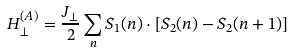<formula> <loc_0><loc_0><loc_500><loc_500>H ^ { ( A ) } _ { \perp } = \frac { J _ { \perp } } { 2 } \sum _ { n } { S } _ { 1 } ( n ) \cdot [ { S } _ { 2 } ( n ) - { S } _ { 2 } ( n + 1 ) ]</formula> 